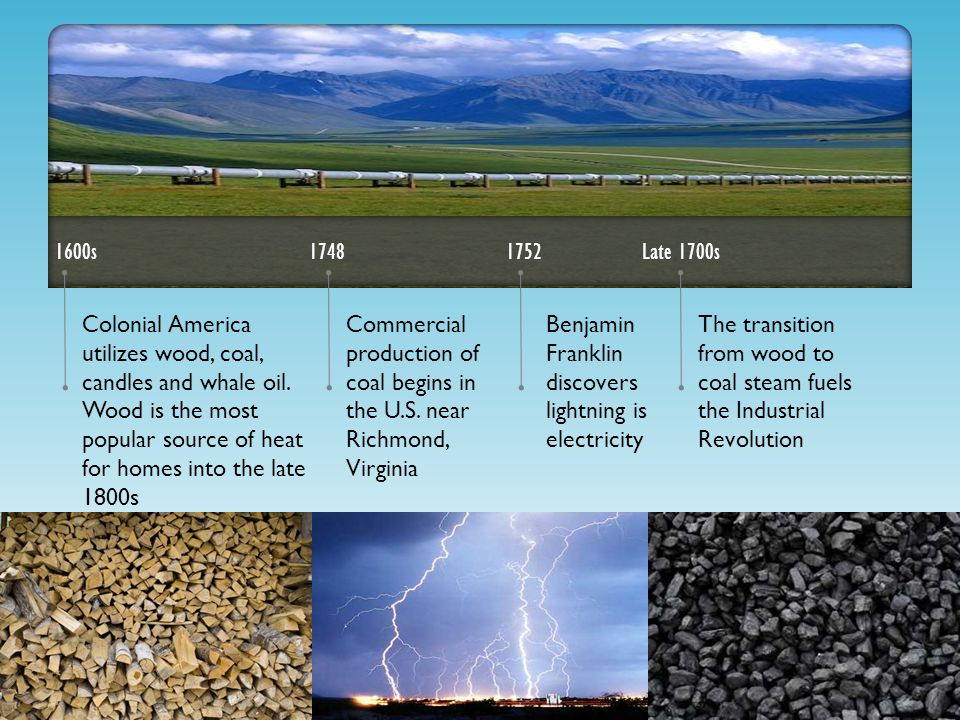What other energy sources besides coal and wood might have been considered or utilized during the late 1700s? During the late 1700s, other energy sources that might have been considered or utilized include water power, which was used in mills to grind grain and in textile manufacturing; and wind power, which was used to pump water and grind grain using windmills. Hydropower was especially important for early industrial sites located near rivers and streams. Additionally, whale oil was still in use for lighting, and it continued to be a significant energy source until kerosene began to replace it in the mid-1800s. 